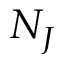<formula> <loc_0><loc_0><loc_500><loc_500>N _ { J }</formula> 